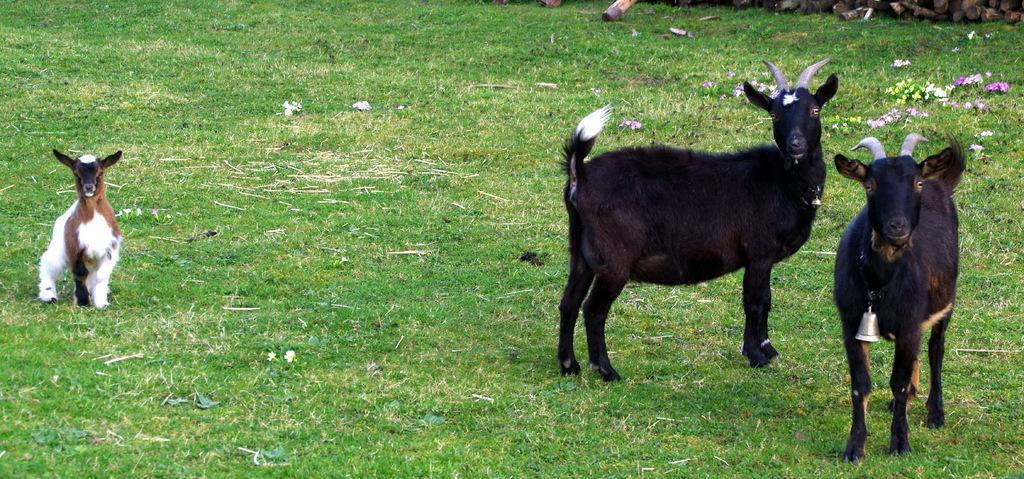Can you describe this image briefly? In this image, we can see some grass and goats. There are flowers in the top right of the image. 